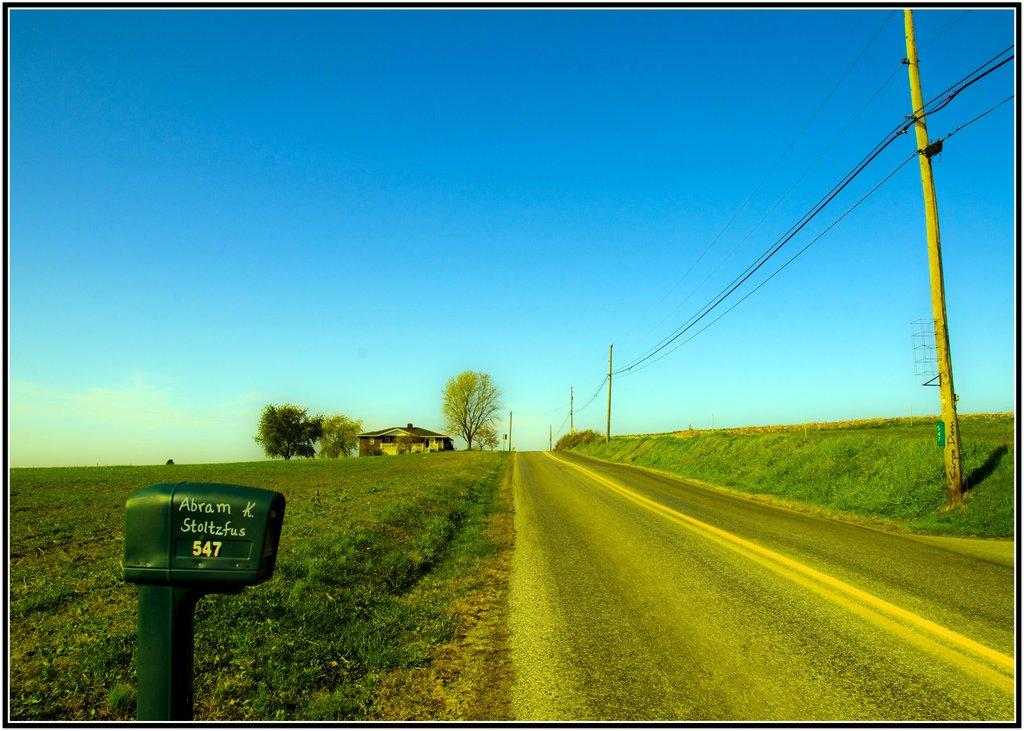What is the main object in the image? There is a post box in the image. What type of natural environment is visible in the image? There is grass, plants, trees, and a cloudy sky visible in the image. What type of man-made structures can be seen in the image? There is a pathway, poles with wires, and a house with a roof in the image. How many different types of structures are present in the image? There are at least four different types of structures present in the image: a post box, a pathway, poles with wires, and a house with a roof. What type of wave can be seen crashing against the post box in the image? There is no wave present in the image; it features a post box, grass, plants, trees, a pathway, poles with wires, a house with a roof, and a cloudy sky. 